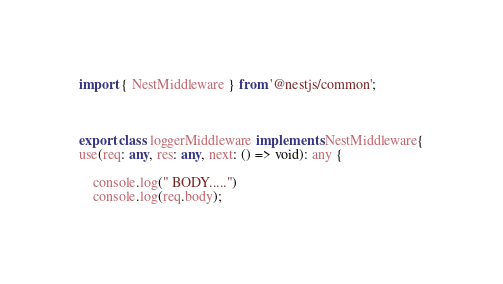<code> <loc_0><loc_0><loc_500><loc_500><_TypeScript_>import { NestMiddleware } from '@nestjs/common';



export class loggerMiddleware implements NestMiddleware{
use(req: any, res: any, next: () => void): any {

    console.log(" BODY.....")
    console.log(req.body);</code> 